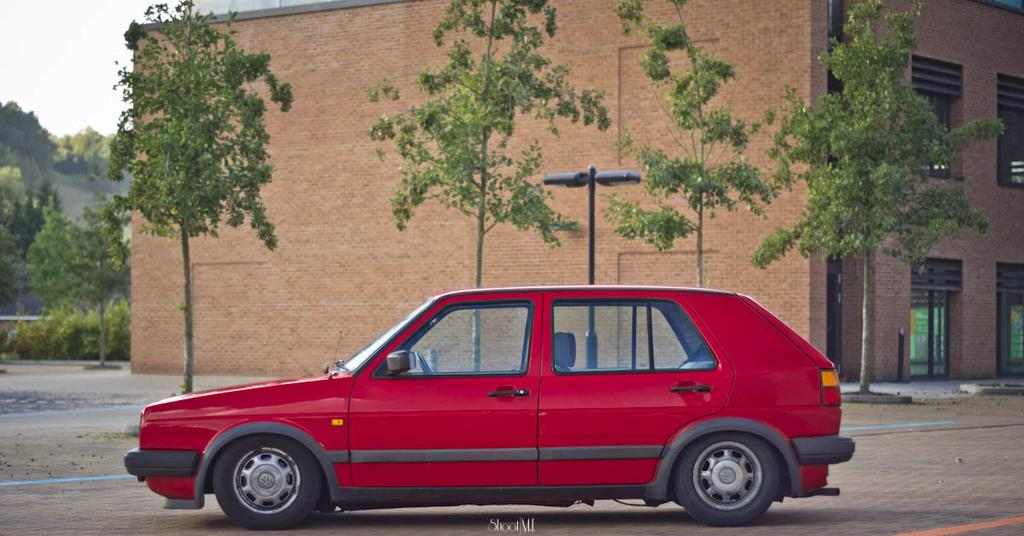What is the main subject of the image? The main subject of the image is a car on the road. What type of natural elements can be seen in the image? There are trees and plants visible in the image. What type of infrastructure is present in the image? There are lights on a pole and a building visible in the image. What is visible in the background of the image? The sky is visible in the background of the image. How does the car contribute to world peace in the image? The car does not contribute to world peace in the image; it is simply a car on the road. What type of nail can be seen holding the building together in the image? There are no nails visible in the image, and the building's construction is not shown in detail. 